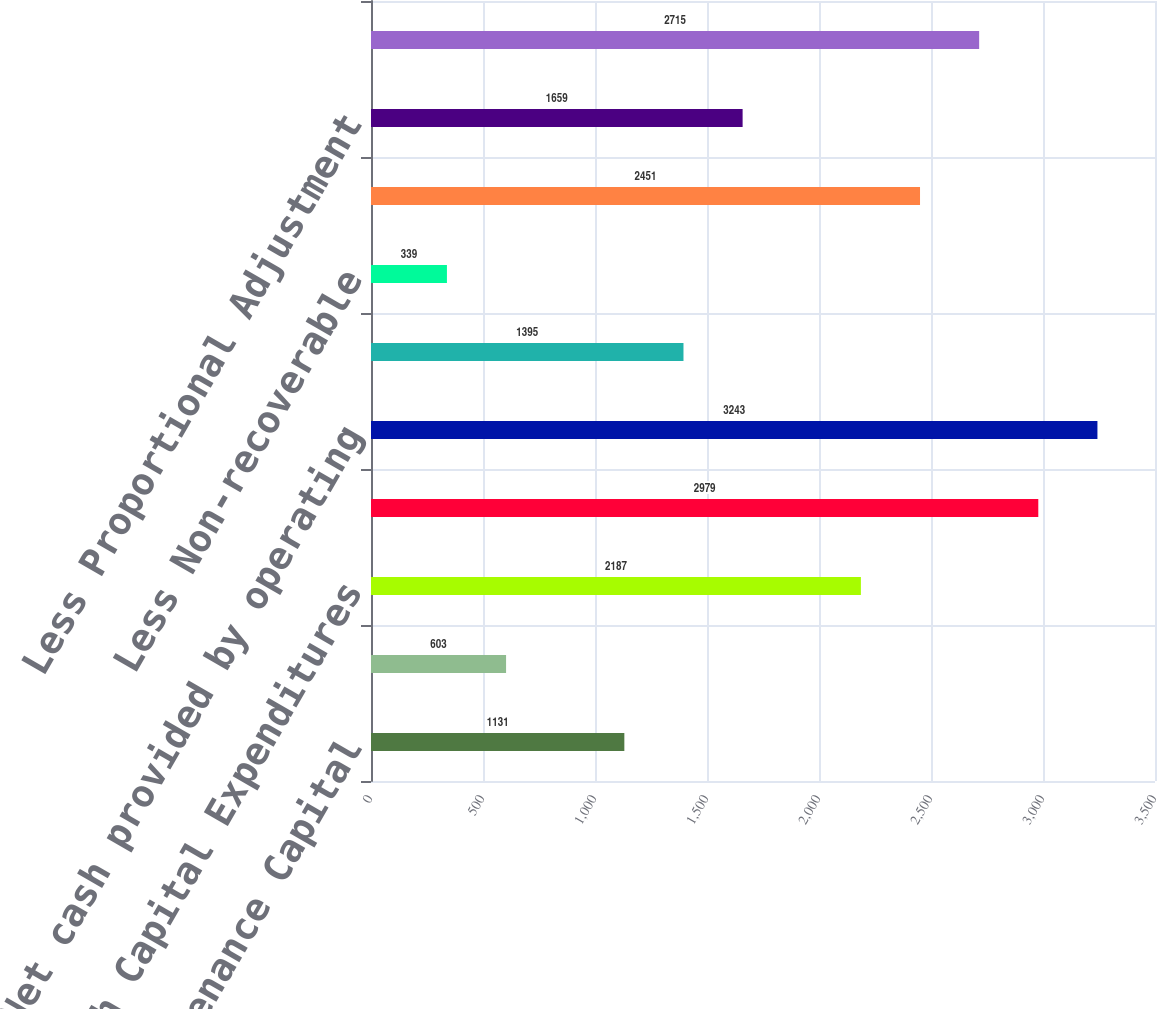Convert chart to OTSL. <chart><loc_0><loc_0><loc_500><loc_500><bar_chart><fcel>Maintenance Capital<fcel>Environmental Capital<fcel>Growth Capital Expenditures<fcel>Total Capital Expenditures<fcel>Net cash provided by operating<fcel>Less Maintenance Capital<fcel>Less Non-recoverable<fcel>Free Cash Flow<fcel>Less Proportional Adjustment<fcel>Proportional Operating Cash<nl><fcel>1131<fcel>603<fcel>2187<fcel>2979<fcel>3243<fcel>1395<fcel>339<fcel>2451<fcel>1659<fcel>2715<nl></chart> 